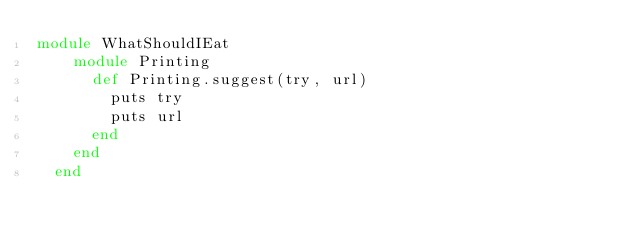<code> <loc_0><loc_0><loc_500><loc_500><_Ruby_>module WhatShouldIEat
    module Printing
      def Printing.suggest(try, url)
        puts try
        puts url
      end
    end
  end</code> 